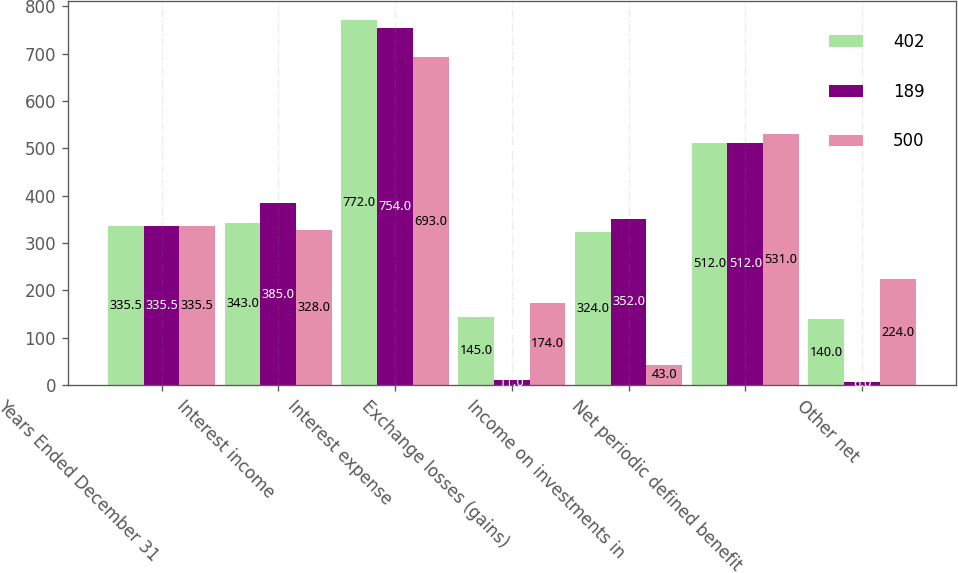<chart> <loc_0><loc_0><loc_500><loc_500><stacked_bar_chart><ecel><fcel>Years Ended December 31<fcel>Interest income<fcel>Interest expense<fcel>Exchange losses (gains)<fcel>Income on investments in<fcel>Net periodic defined benefit<fcel>Other net<nl><fcel>402<fcel>335.5<fcel>343<fcel>772<fcel>145<fcel>324<fcel>512<fcel>140<nl><fcel>189<fcel>335.5<fcel>385<fcel>754<fcel>11<fcel>352<fcel>512<fcel>6<nl><fcel>500<fcel>335.5<fcel>328<fcel>693<fcel>174<fcel>43<fcel>531<fcel>224<nl></chart> 